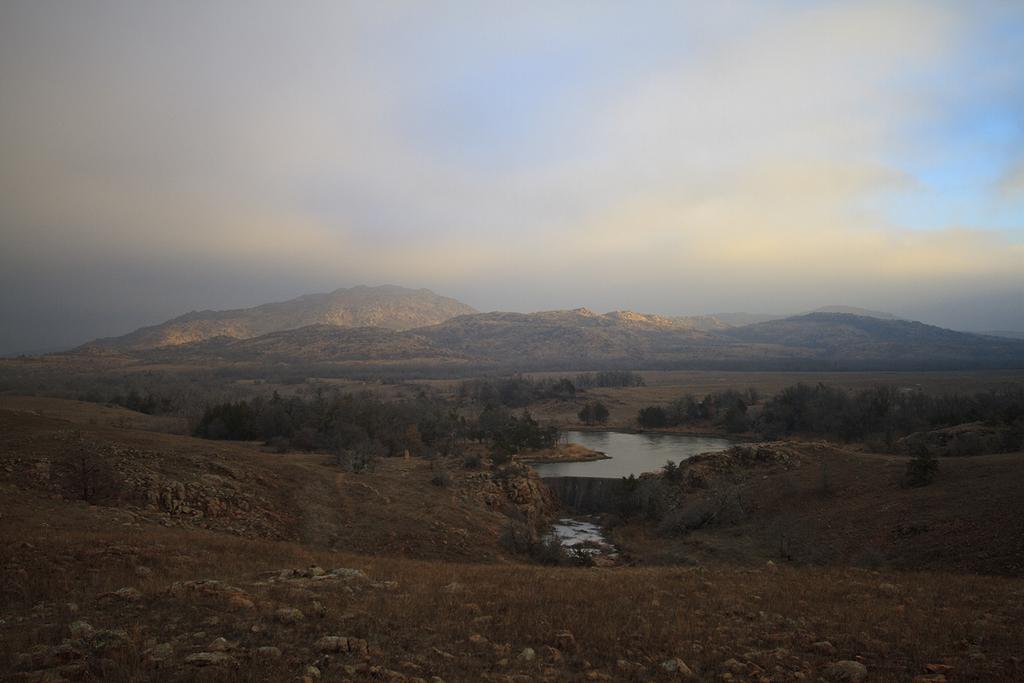Could you give a brief overview of what you see in this image? In this picture I can observe some trees on the land. In the middle of the picture there is a pond. In the background there are hills and some clouds in the sky. 